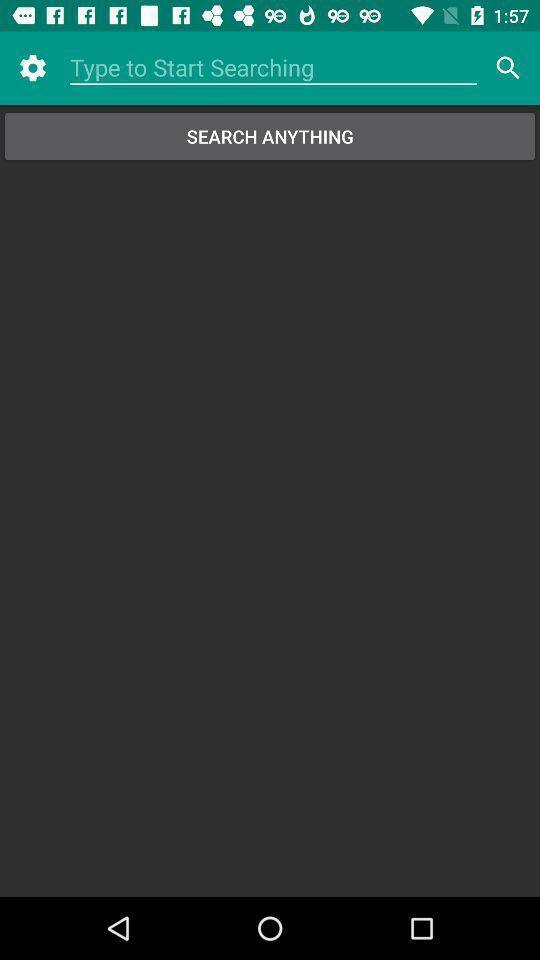Describe the visual elements of this screenshot. Search bar in settings page. 